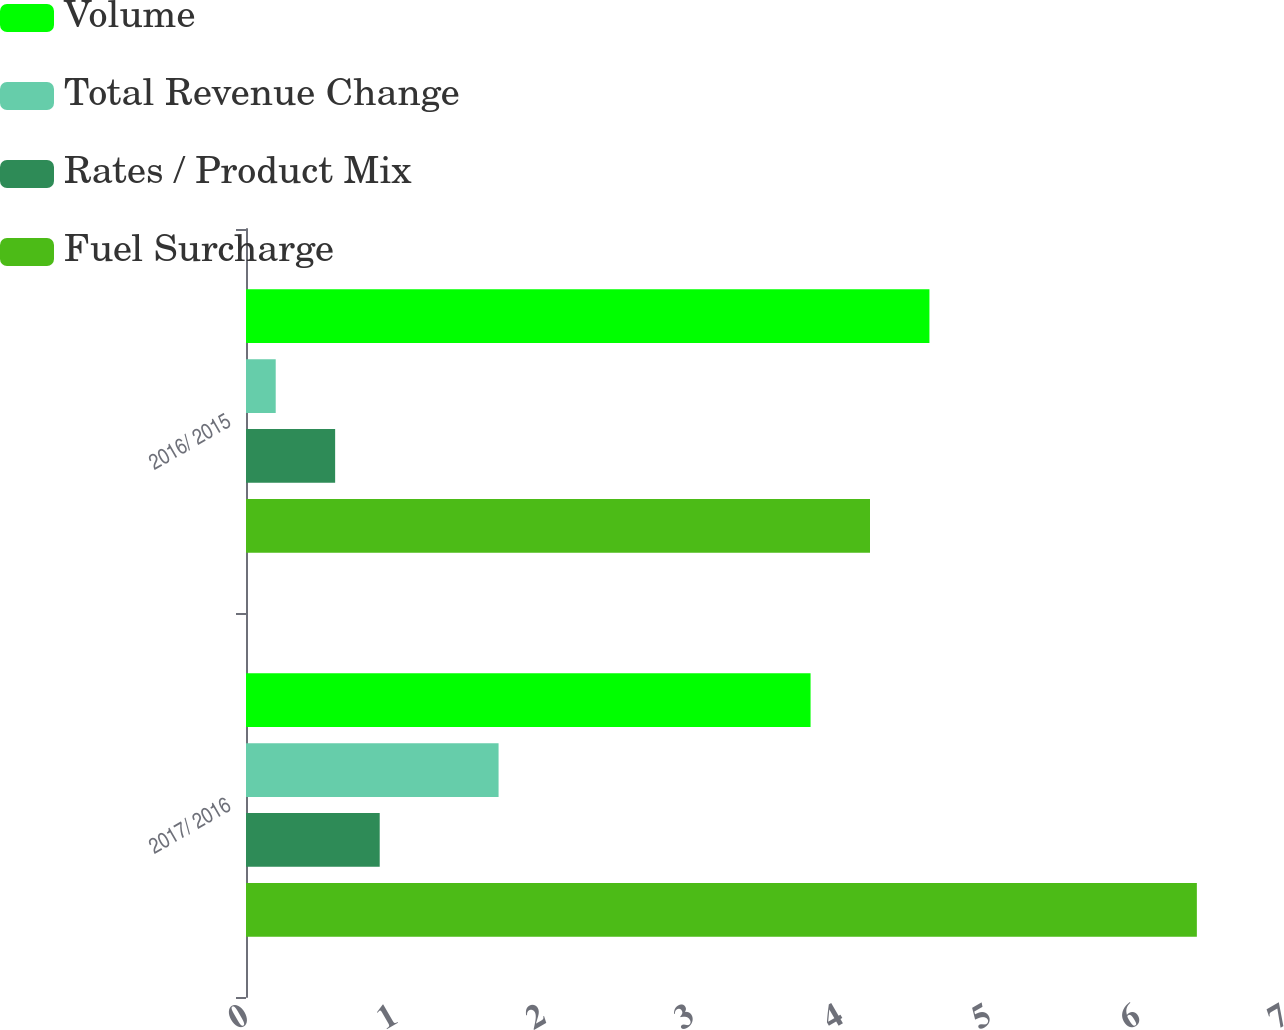Convert chart to OTSL. <chart><loc_0><loc_0><loc_500><loc_500><stacked_bar_chart><ecel><fcel>2017/ 2016<fcel>2016/ 2015<nl><fcel>Volume<fcel>3.8<fcel>4.6<nl><fcel>Total Revenue Change<fcel>1.7<fcel>0.2<nl><fcel>Rates / Product Mix<fcel>0.9<fcel>0.6<nl><fcel>Fuel Surcharge<fcel>6.4<fcel>4.2<nl></chart> 